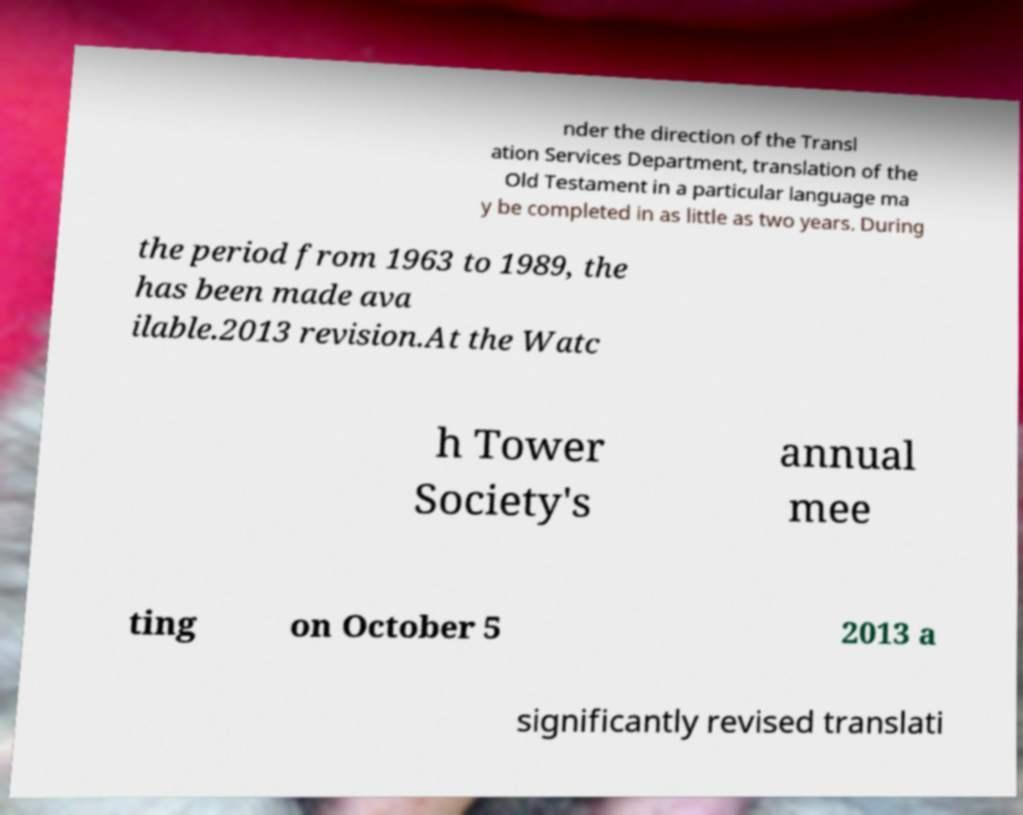Can you read and provide the text displayed in the image?This photo seems to have some interesting text. Can you extract and type it out for me? nder the direction of the Transl ation Services Department, translation of the Old Testament in a particular language ma y be completed in as little as two years. During the period from 1963 to 1989, the has been made ava ilable.2013 revision.At the Watc h Tower Society's annual mee ting on October 5 2013 a significantly revised translati 